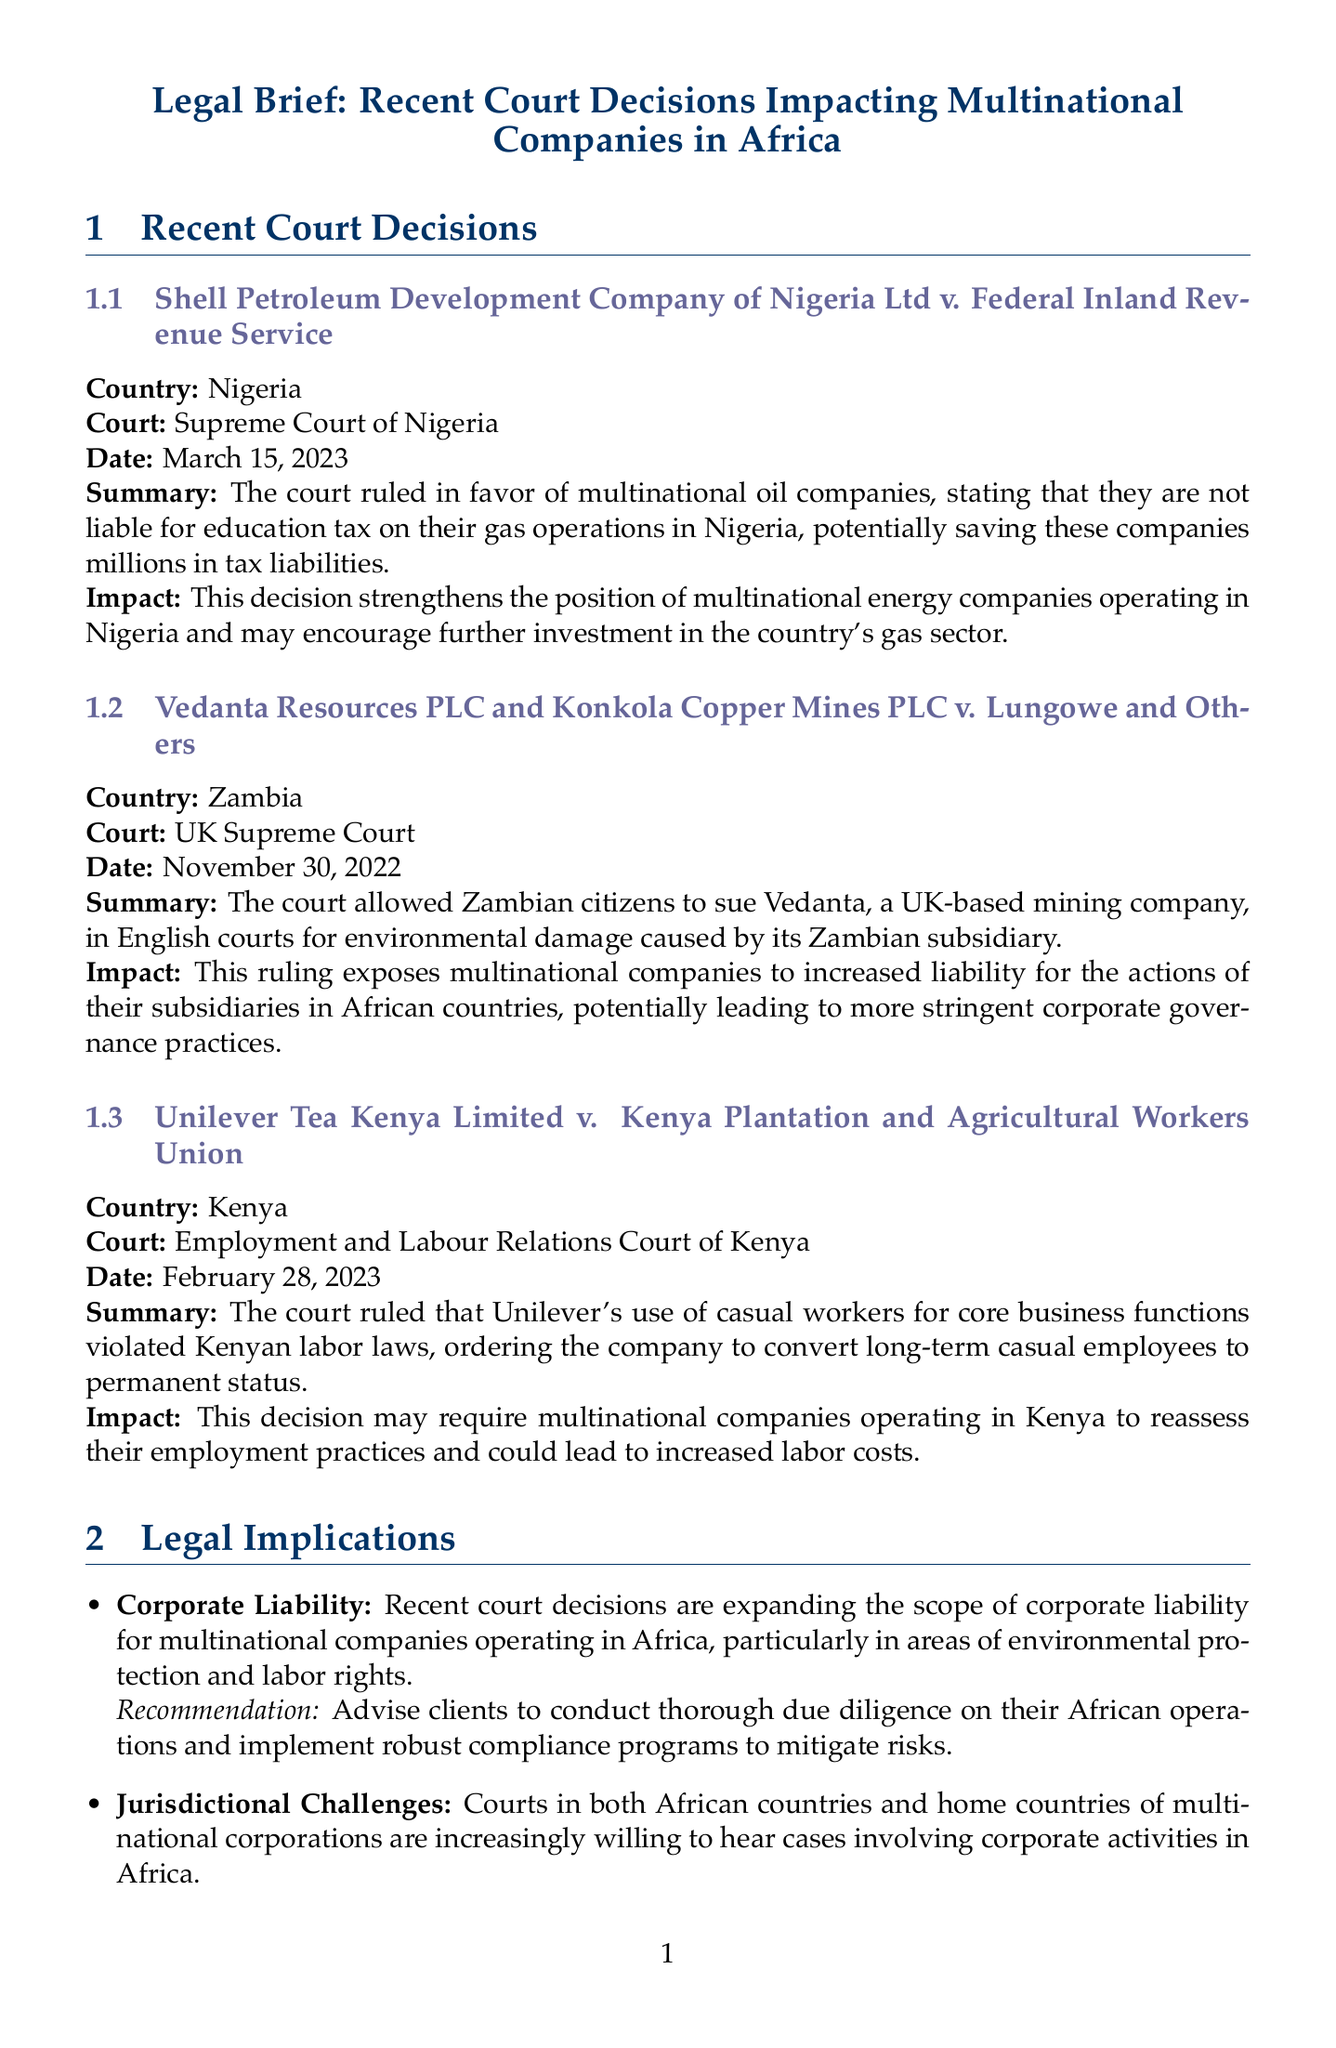what is the case name involving Shell Petroleum? The case name is mentioned under the recent court decisions and is titled "Shell Petroleum Development Company of Nigeria Ltd v. Federal Inland Revenue Service."
Answer: Shell Petroleum Development Company of Nigeria Ltd v. Federal Inland Revenue Service what was the court ruling date for Unilever Tea Kenya Limited? The ruling date for Unilever Tea Kenya Limited is specified in the document.
Answer: February 28, 2023 which court ruled on the Vedanta Resources case? The document lists the court that ruled and it is the "UK Supreme Court."
Answer: UK Supreme Court what impact did the Nigeria ruling have on multinational companies? The document discusses the impact of the ruling and states it encourages further investment in the gas sector in Nigeria.
Answer: Encourages further investment in the gas sector what topic is related to the increased scrutiny of corporate tax practices? The topic is noted in the legal implications section concerning the increased scrutiny of corporate tax practices.
Answer: Tax Implications which agreement aims to create a single market for goods and services across Africa? The agreement is a crucial element discussed in the relevant legislation section of the document.
Answer: African Continental Free Trade Area (AfCFTA) Agreement what is a recommended action for clients regarding jurisdictional challenges? The recommendations for jurisdictional challenges are described under legal implications in the document.
Answer: Maintain consistent corporate standards across all operations how does the court ruling in Zambia impact multinational companies? The document explains the implications of this ruling for corporate governance practices.
Answer: Increased liability for actions of subsidiaries 